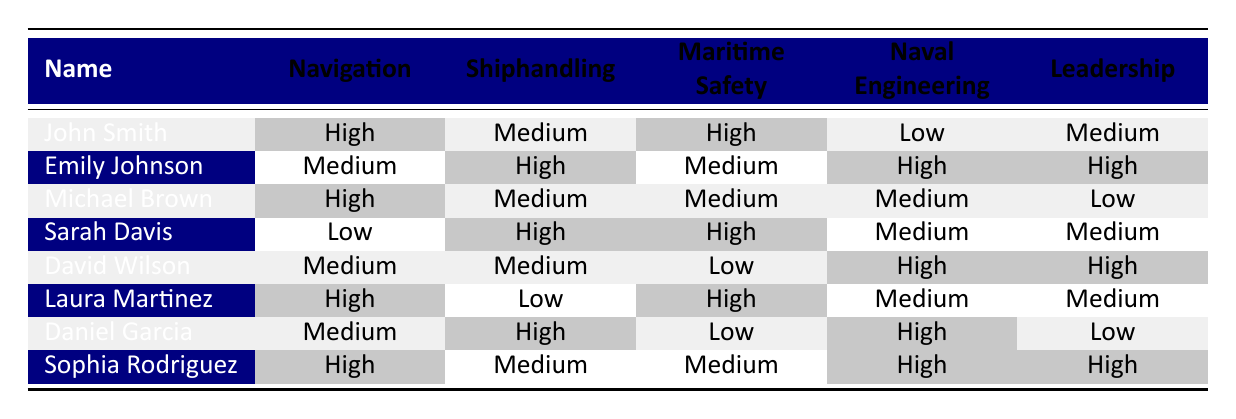What is John Smith's proficiency level in naval engineering? According to the table, John's proficiency level in naval engineering is listed as low.
Answer: Low Which student has the highest proficiency in shiphandling? Emily Johnson has the highest proficiency in shiphandling marked as high.
Answer: Emily Johnson How many students have a medium proficiency in leadership? The table shows Emily Johnson, David Wilson, and Laura Martinez as having a medium proficiency level in leadership. This amounts to three students with medium proficiency in leadership.
Answer: 3 Is it true that Sarah Davis has a low proficiency level in navigation? The table indicates that Sarah Davis has a low proficiency in navigation, making the statement true.
Answer: Yes Which students have a high proficiency in maritime safety? The students with high proficiency in maritime safety are John Smith, Sarah Davis, and Laura Martinez. So, there are three students with this proficiency.
Answer: 3 What is the average proficiency level of the students in naval engineering? The students' proficiency levels in naval engineering are low, high, medium, medium, high, medium, high, and high. Converting these levels to numerical values (low = 1, medium = 2, high = 3), we have the following numbers: 1, 3, 2, 2, 3, 2, 3, 3. The sum is 19 and there are 8 students, so the average is 19/8 = 2.375, which corresponds to a medium level.
Answer: Medium How many students scored high in both navigation and leadership? Checking the table, John Smith and Sophia Rodriguez both scored high in navigation and leadership. Thus, there are two students who meet this criteria.
Answer: 2 Does any student have a low proficiency in both maritime safety and leadership? Looking at the table, Daniel Garcia has a low proficiency in maritime safety and leadership, confirming that the statement is true.
Answer: Yes Which student has the lowest proficiency level across all subjects? By comparing all proficiency levels listed, Daniel Garcia has a low level in leadership and low in maritime safety, making his overall proficiency the lowest.
Answer: Daniel Garcia 